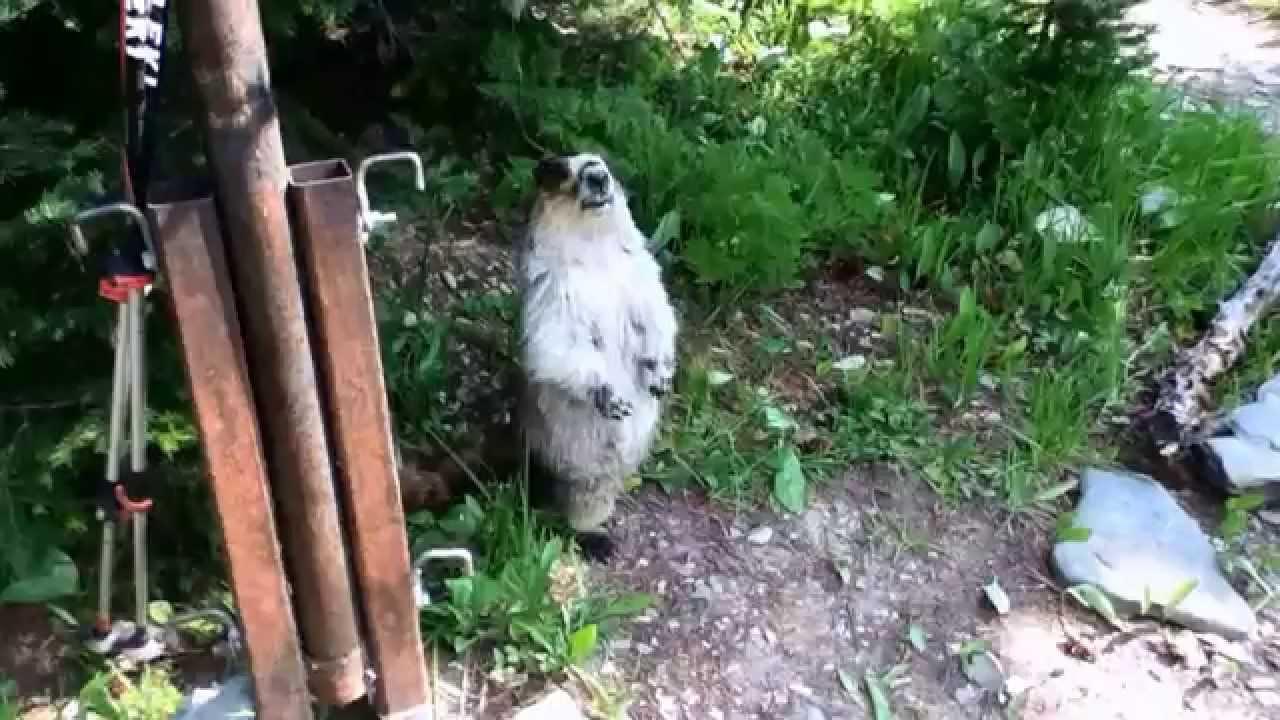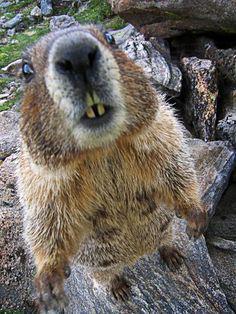The first image is the image on the left, the second image is the image on the right. Examine the images to the left and right. Is the description "There are two marmots, and both stand upright with front paws dangling." accurate? Answer yes or no. Yes. 